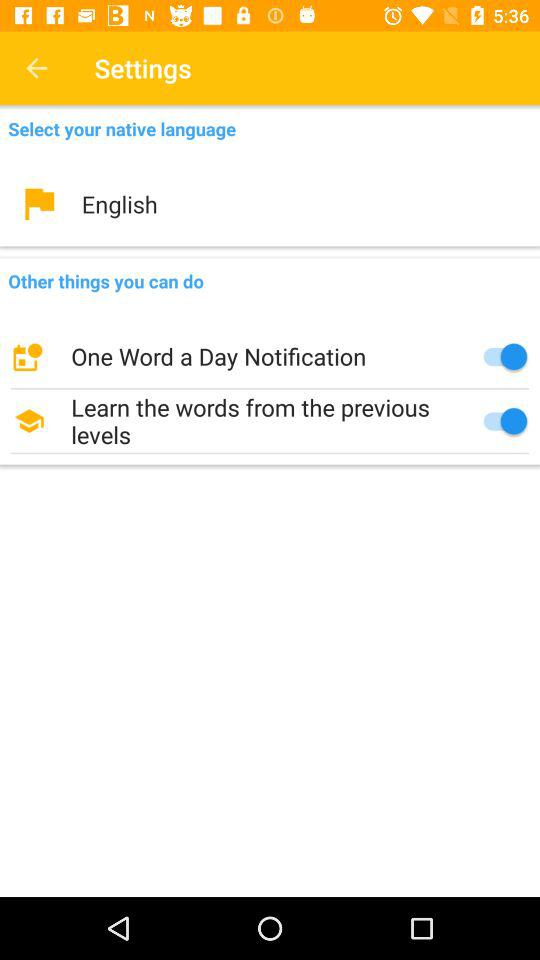What is the status of the "One Word a Day Notification" setting? The status is "on". 